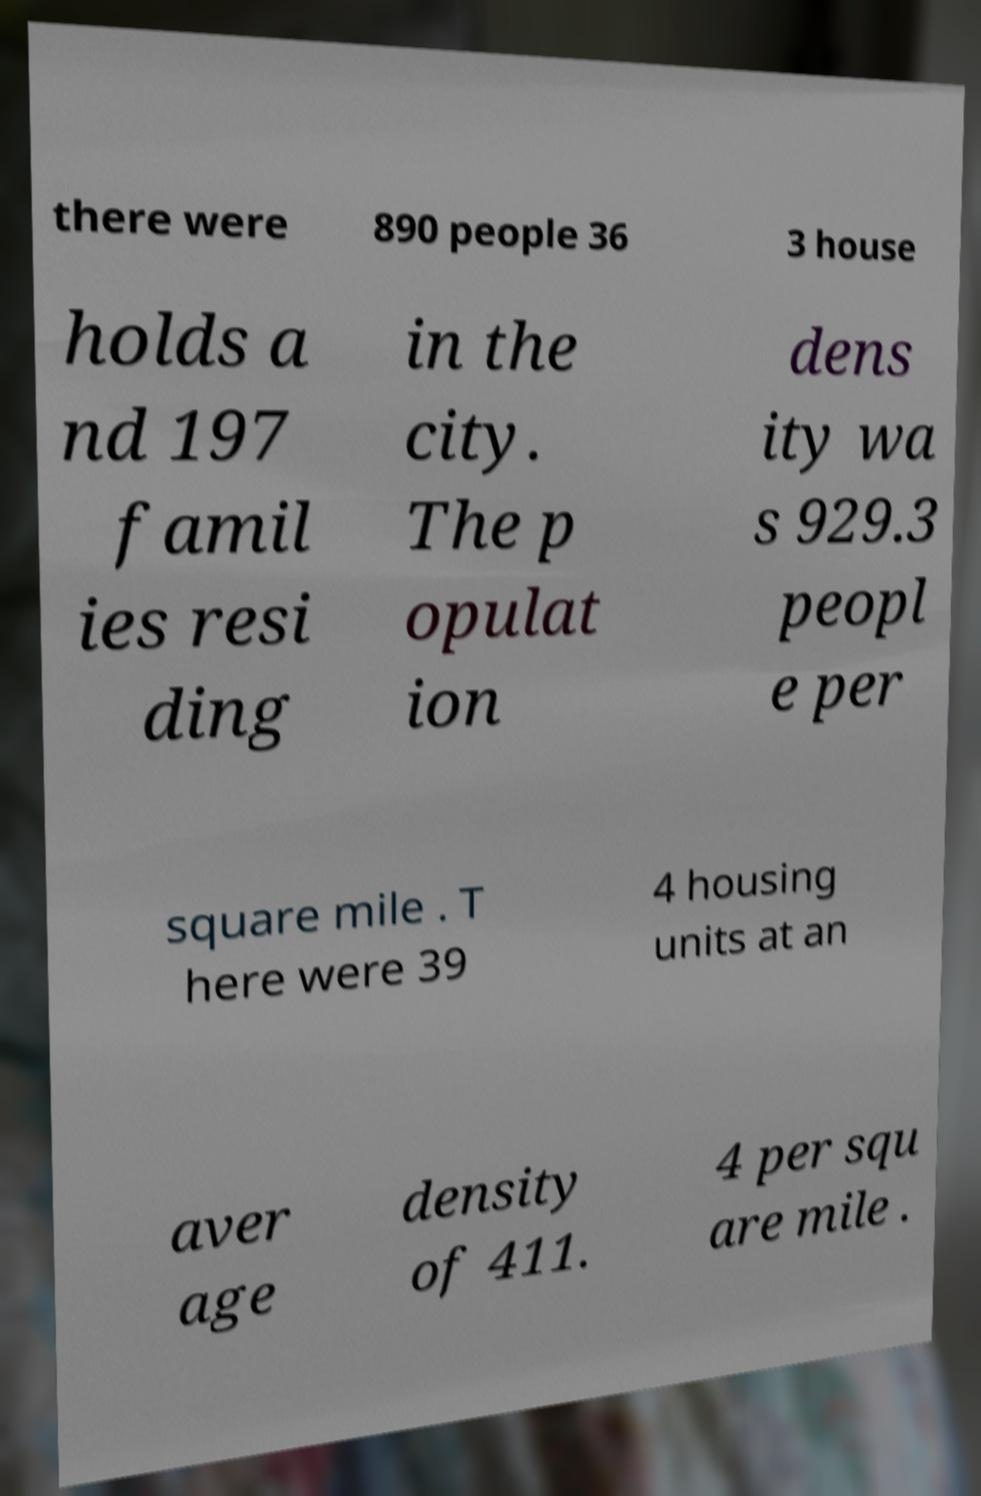What messages or text are displayed in this image? I need them in a readable, typed format. there were 890 people 36 3 house holds a nd 197 famil ies resi ding in the city. The p opulat ion dens ity wa s 929.3 peopl e per square mile . T here were 39 4 housing units at an aver age density of 411. 4 per squ are mile . 